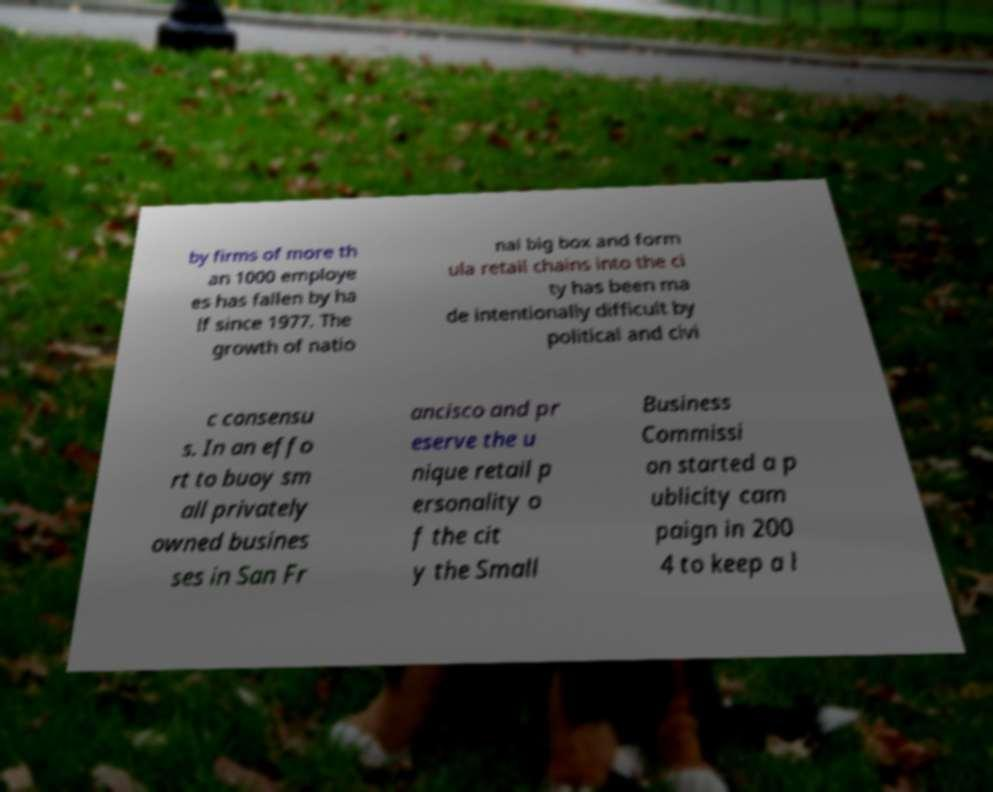I need the written content from this picture converted into text. Can you do that? by firms of more th an 1000 employe es has fallen by ha lf since 1977. The growth of natio nal big box and form ula retail chains into the ci ty has been ma de intentionally difficult by political and civi c consensu s. In an effo rt to buoy sm all privately owned busines ses in San Fr ancisco and pr eserve the u nique retail p ersonality o f the cit y the Small Business Commissi on started a p ublicity cam paign in 200 4 to keep a l 